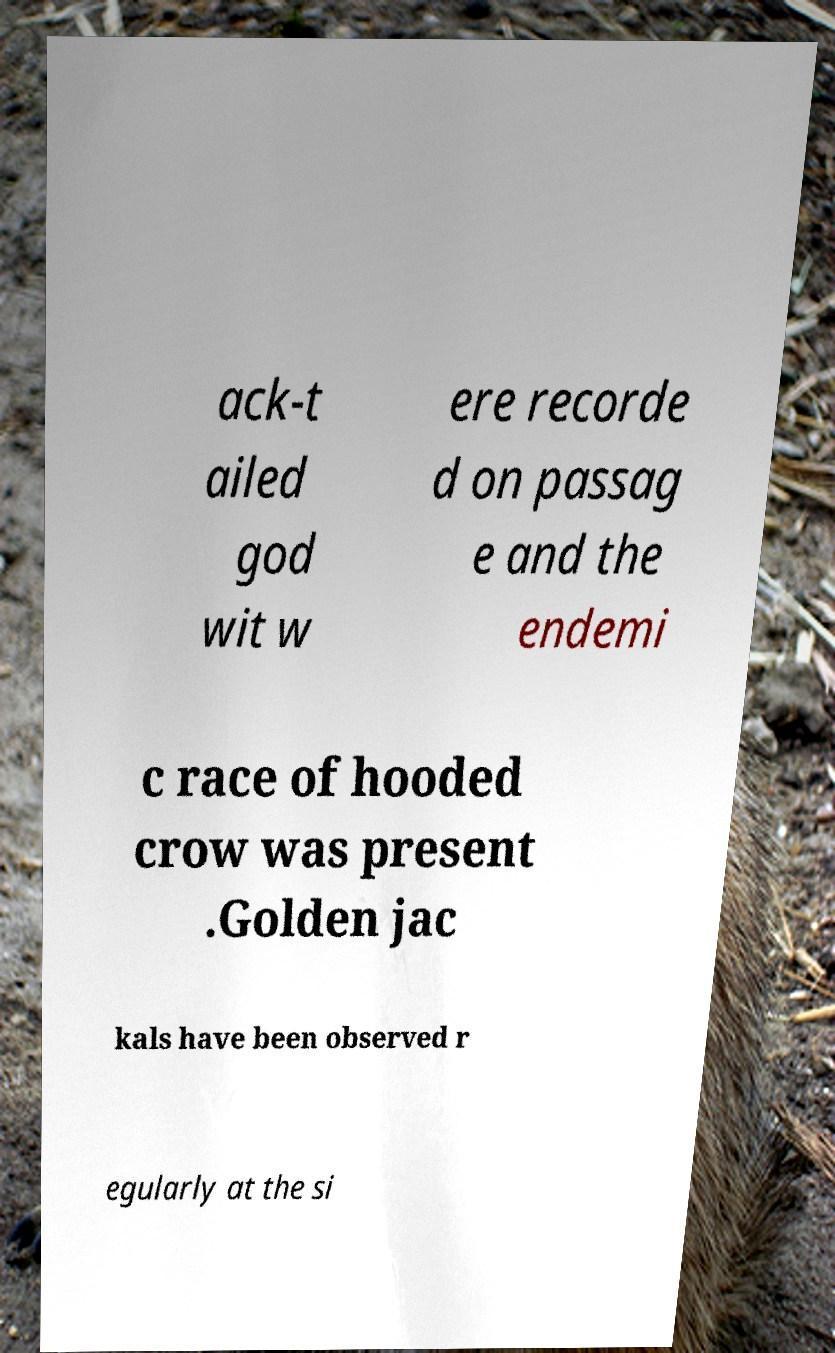Can you read and provide the text displayed in the image?This photo seems to have some interesting text. Can you extract and type it out for me? ack-t ailed god wit w ere recorde d on passag e and the endemi c race of hooded crow was present .Golden jac kals have been observed r egularly at the si 